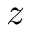<formula> <loc_0><loc_0><loc_500><loc_500>z</formula> 